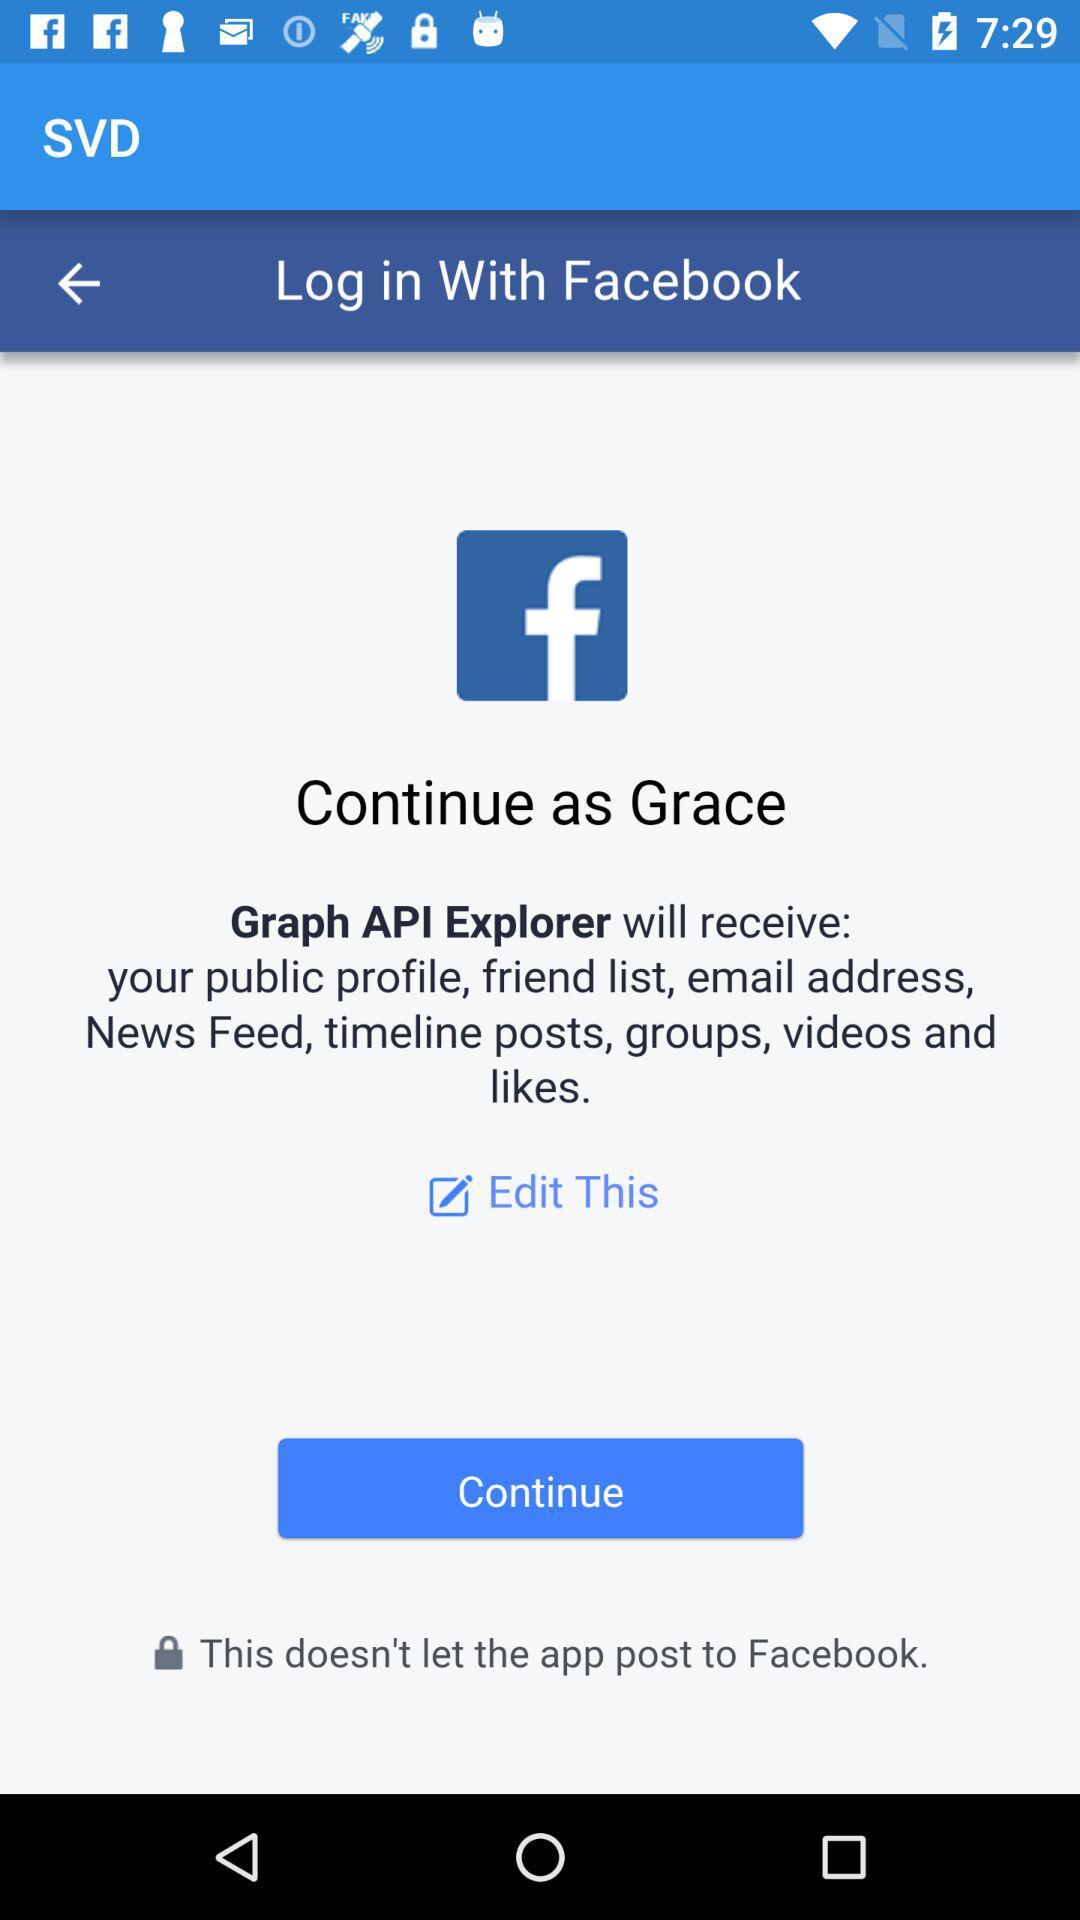What is the user name? The user name is Grace. 